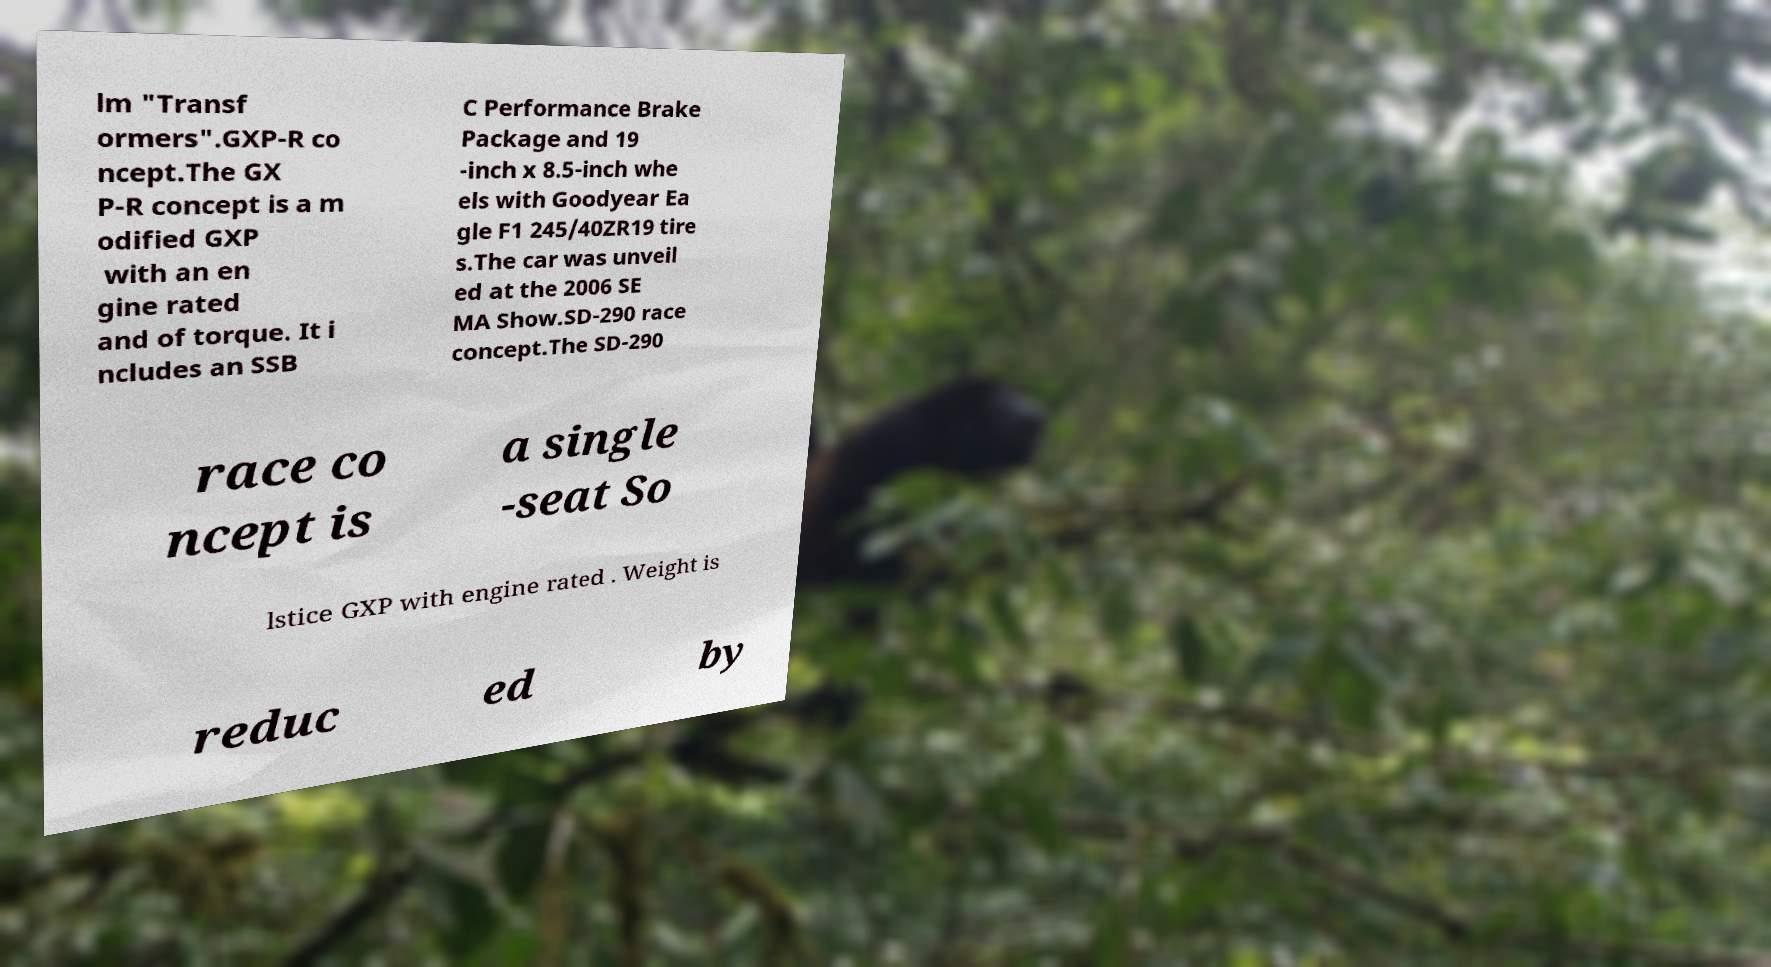I need the written content from this picture converted into text. Can you do that? lm "Transf ormers".GXP-R co ncept.The GX P-R concept is a m odified GXP with an en gine rated and of torque. It i ncludes an SSB C Performance Brake Package and 19 -inch x 8.5-inch whe els with Goodyear Ea gle F1 245/40ZR19 tire s.The car was unveil ed at the 2006 SE MA Show.SD-290 race concept.The SD-290 race co ncept is a single -seat So lstice GXP with engine rated . Weight is reduc ed by 